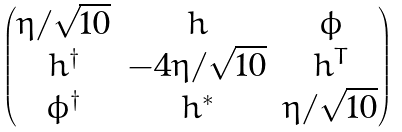Convert formula to latex. <formula><loc_0><loc_0><loc_500><loc_500>\begin{pmatrix} \eta / \sqrt { 1 0 } & h & \phi \\ h ^ { \dagger } & - 4 \eta / \sqrt { 1 0 } & h ^ { T } \\ \phi ^ { \dagger } & h ^ { * } & \eta / \sqrt { 1 0 } \end{pmatrix}</formula> 